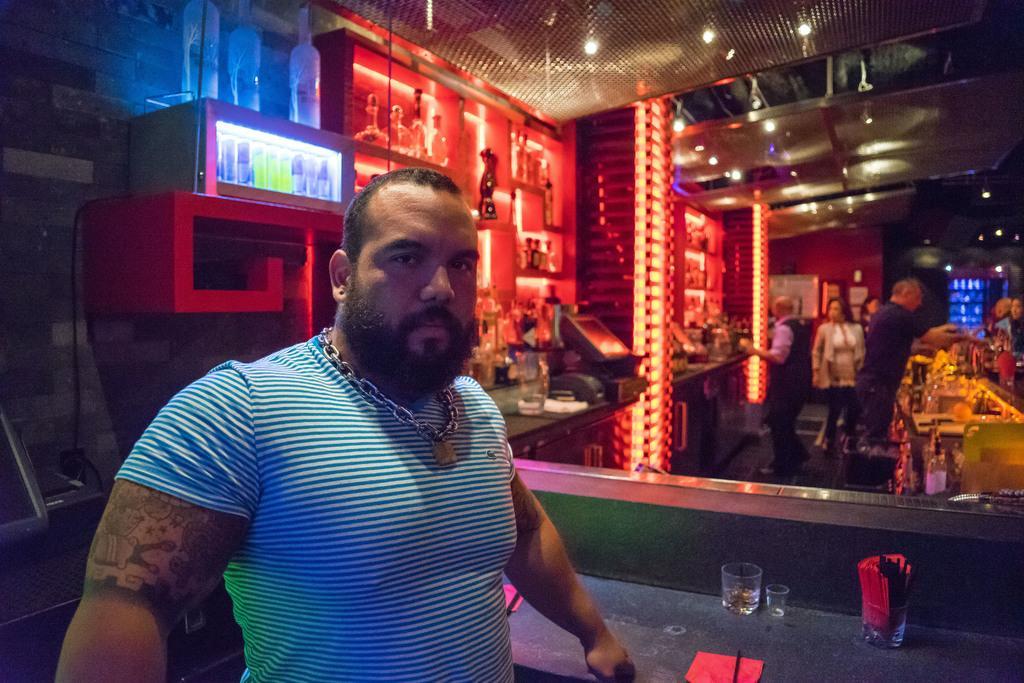Describe this image in one or two sentences. In this image in the foreground there is one man, and in the background there are some persons, lights, tables and some other objects. And in the center there are some shelves, in the shelves there are some toys and some other objects. At the bottom there is a table, on the table there are some glasses and some papers. On the left side there is a wall, and some other objects. 